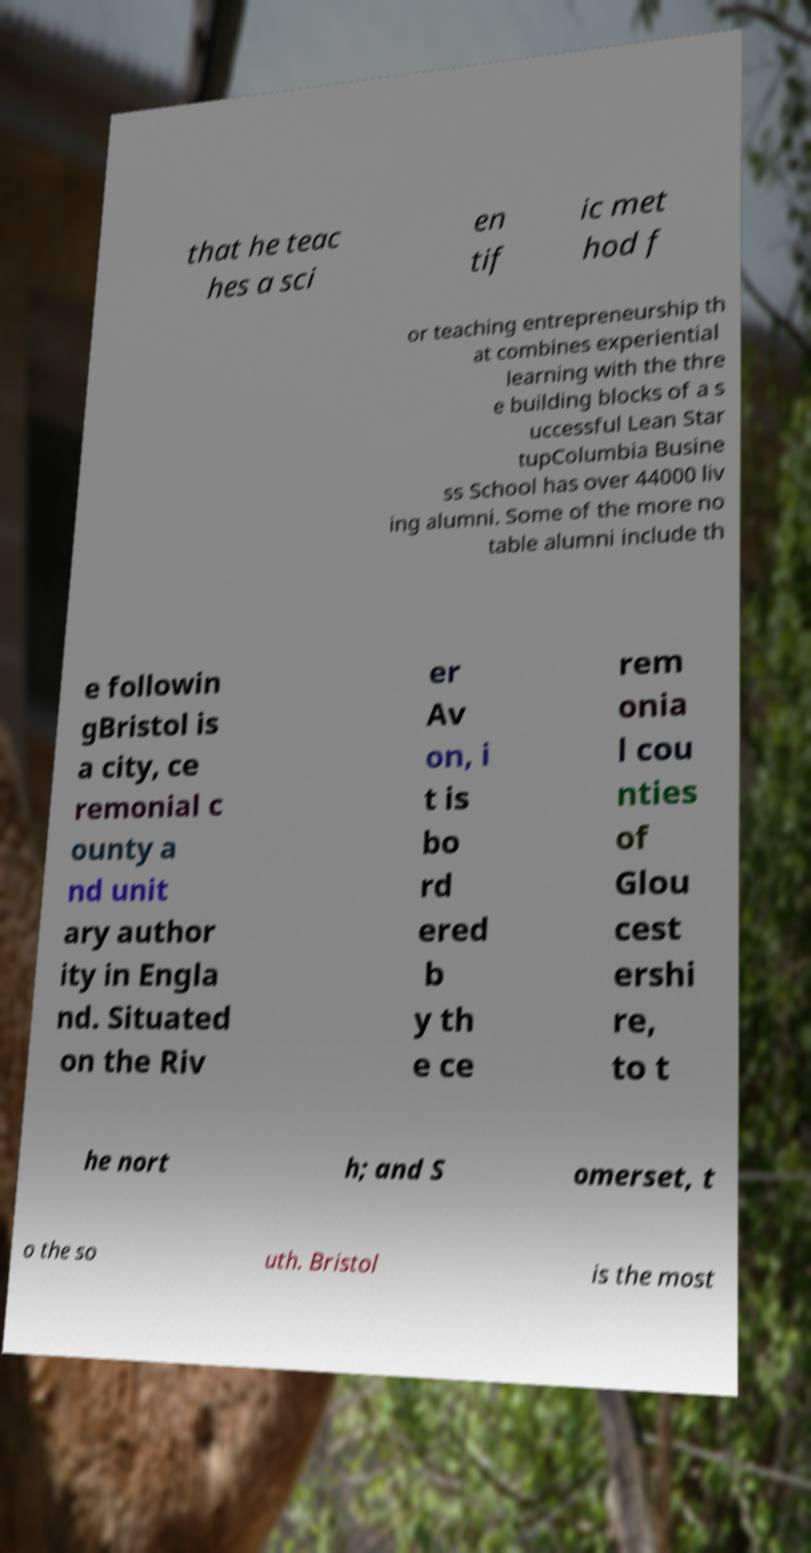Could you assist in decoding the text presented in this image and type it out clearly? that he teac hes a sci en tif ic met hod f or teaching entrepreneurship th at combines experiential learning with the thre e building blocks of a s uccessful Lean Star tupColumbia Busine ss School has over 44000 liv ing alumni. Some of the more no table alumni include th e followin gBristol is a city, ce remonial c ounty a nd unit ary author ity in Engla nd. Situated on the Riv er Av on, i t is bo rd ered b y th e ce rem onia l cou nties of Glou cest ershi re, to t he nort h; and S omerset, t o the so uth. Bristol is the most 